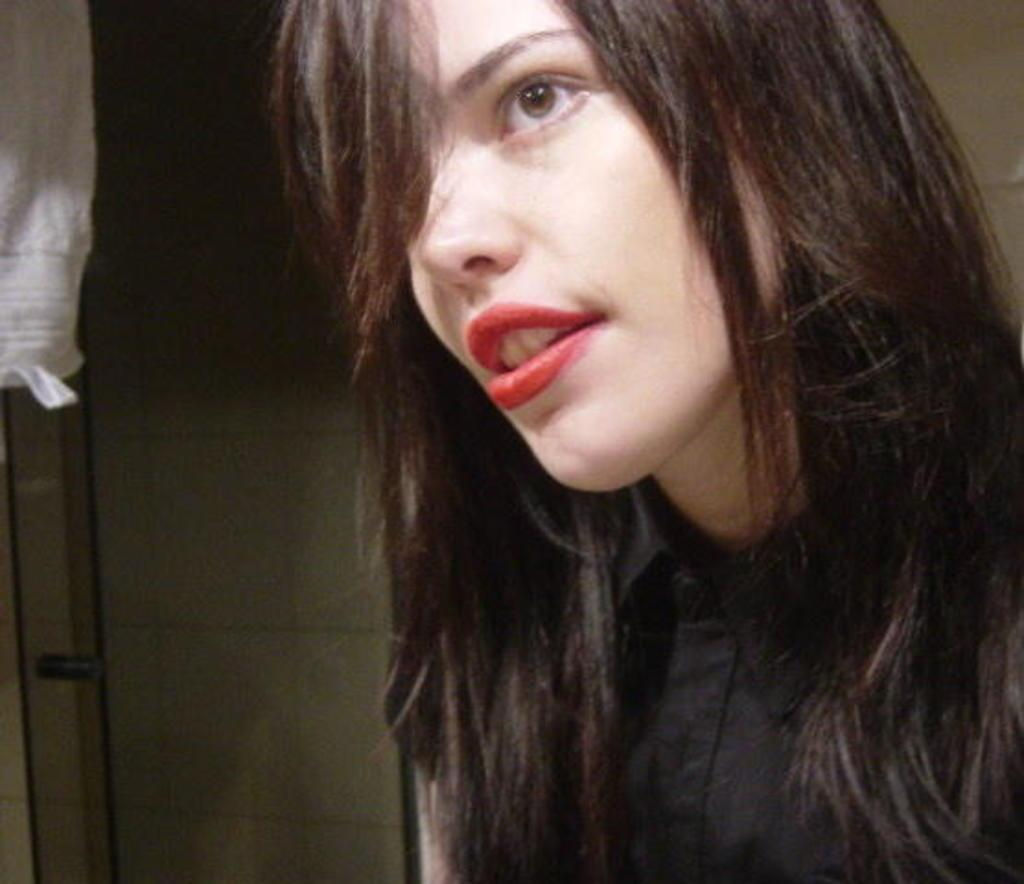Who is present in the image? There is a woman in the image. What is the woman wearing? The woman is wearing a black shirt. What can be seen behind the woman? There is a wall behind the woman. What is the texture of the woman's hair in the image? The texture of the woman's hair cannot be determined from the image, as it is not detailed enough to provide that information. 